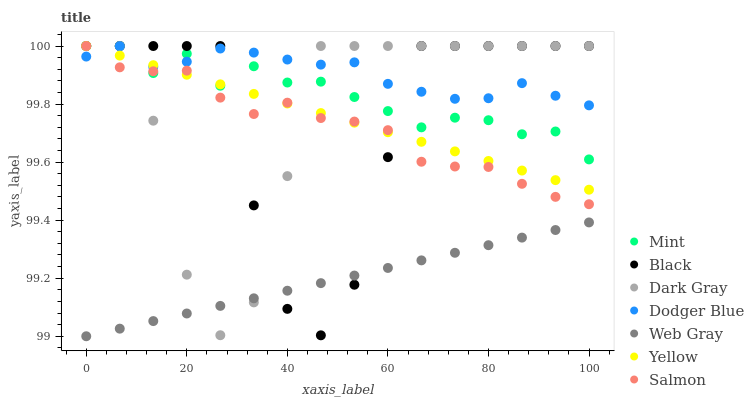Does Web Gray have the minimum area under the curve?
Answer yes or no. Yes. Does Dodger Blue have the maximum area under the curve?
Answer yes or no. Yes. Does Salmon have the minimum area under the curve?
Answer yes or no. No. Does Salmon have the maximum area under the curve?
Answer yes or no. No. Is Web Gray the smoothest?
Answer yes or no. Yes. Is Black the roughest?
Answer yes or no. Yes. Is Salmon the smoothest?
Answer yes or no. No. Is Salmon the roughest?
Answer yes or no. No. Does Web Gray have the lowest value?
Answer yes or no. Yes. Does Salmon have the lowest value?
Answer yes or no. No. Does Mint have the highest value?
Answer yes or no. Yes. Does Dodger Blue have the highest value?
Answer yes or no. No. Is Web Gray less than Yellow?
Answer yes or no. Yes. Is Yellow greater than Web Gray?
Answer yes or no. Yes. Does Salmon intersect Dodger Blue?
Answer yes or no. Yes. Is Salmon less than Dodger Blue?
Answer yes or no. No. Is Salmon greater than Dodger Blue?
Answer yes or no. No. Does Web Gray intersect Yellow?
Answer yes or no. No. 